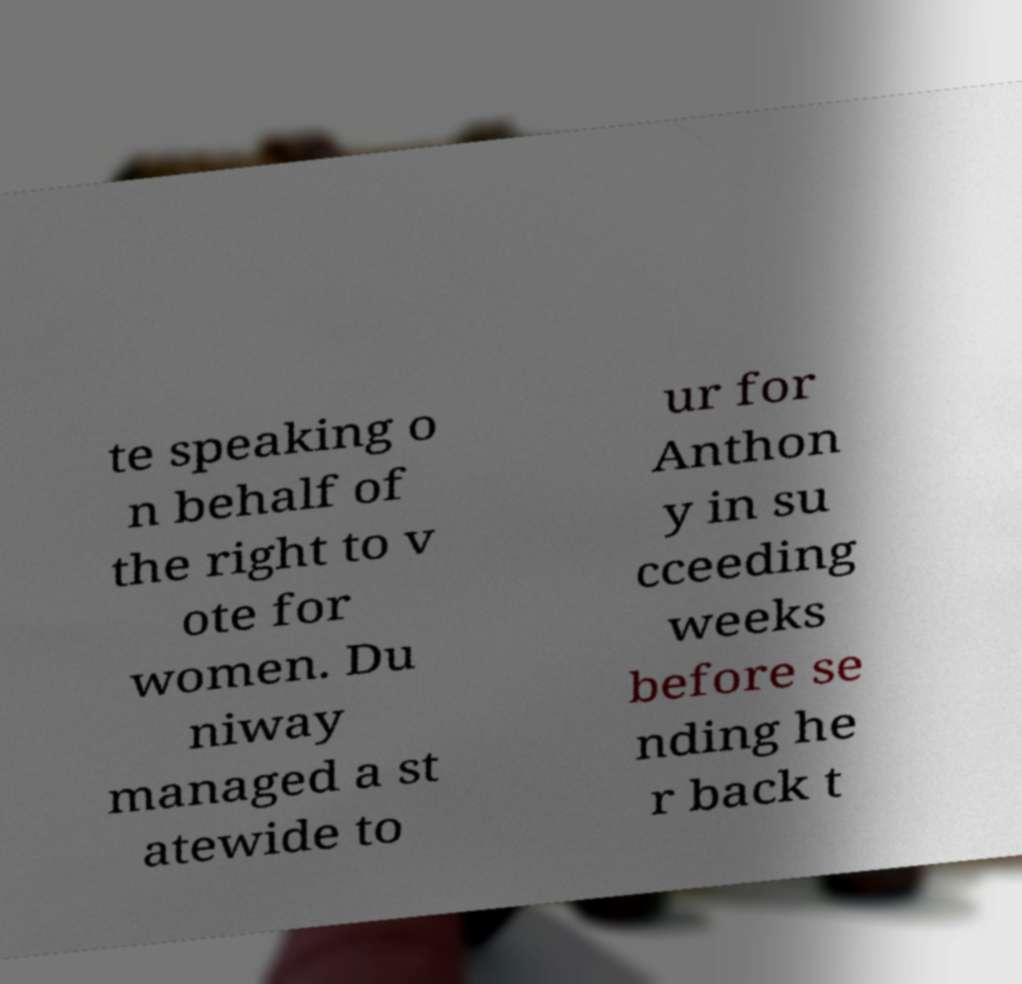Please identify and transcribe the text found in this image. te speaking o n behalf of the right to v ote for women. Du niway managed a st atewide to ur for Anthon y in su cceeding weeks before se nding he r back t 